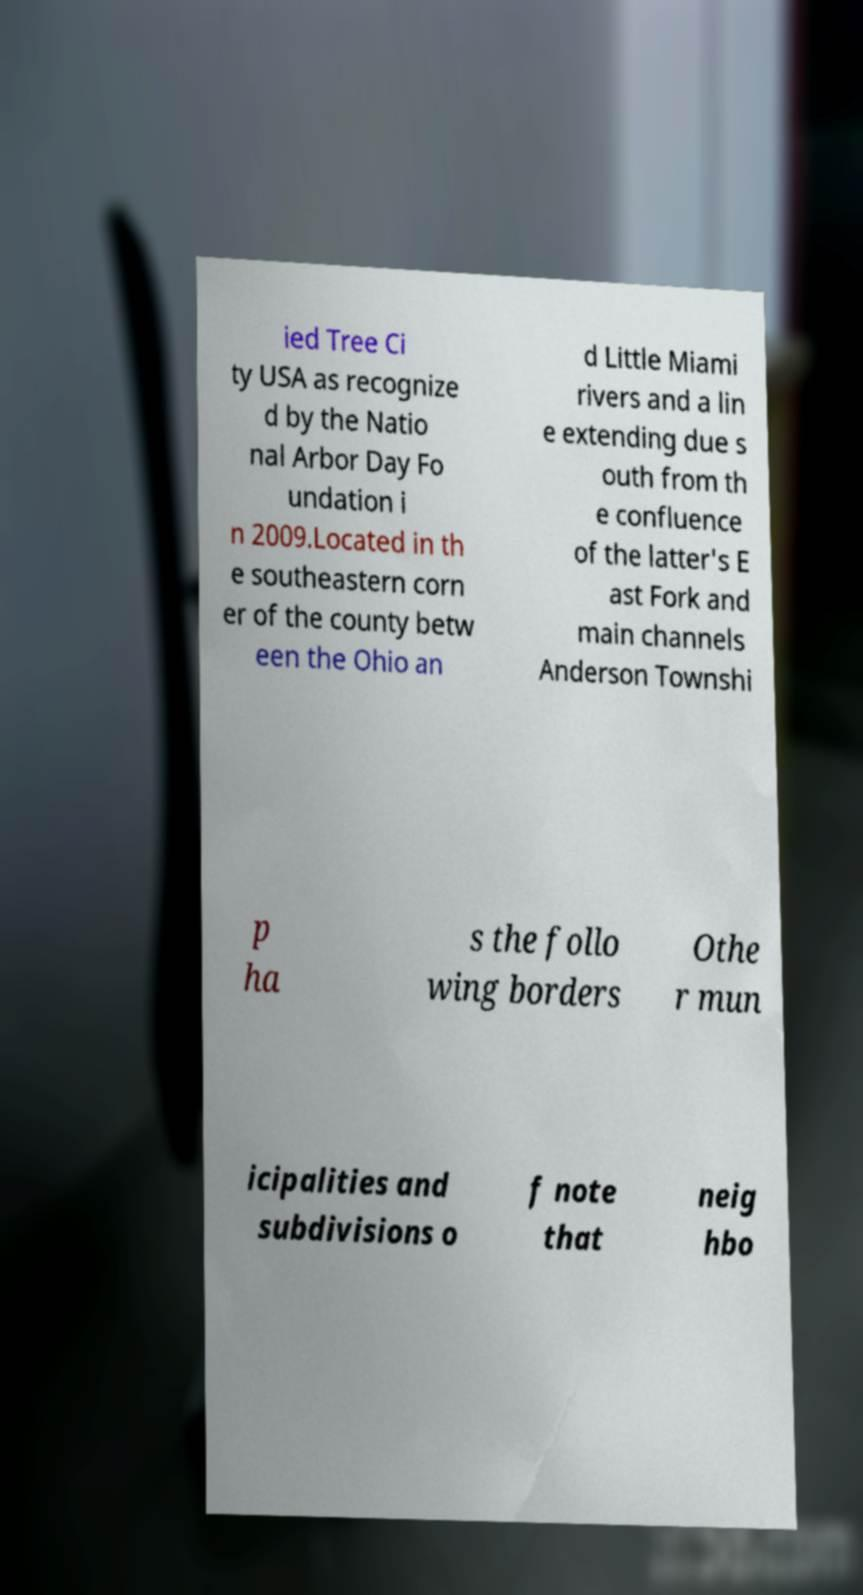Please identify and transcribe the text found in this image. ied Tree Ci ty USA as recognize d by the Natio nal Arbor Day Fo undation i n 2009.Located in th e southeastern corn er of the county betw een the Ohio an d Little Miami rivers and a lin e extending due s outh from th e confluence of the latter's E ast Fork and main channels Anderson Townshi p ha s the follo wing borders Othe r mun icipalities and subdivisions o f note that neig hbo 